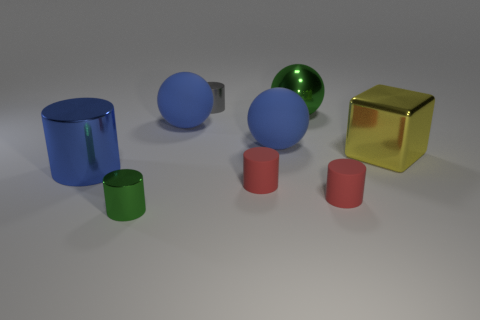Subtract all green cylinders. How many cylinders are left? 4 Subtract all green spheres. How many spheres are left? 2 Subtract 1 green spheres. How many objects are left? 8 Subtract all cylinders. How many objects are left? 4 Subtract 1 cubes. How many cubes are left? 0 Subtract all yellow cylinders. Subtract all blue spheres. How many cylinders are left? 5 Subtract all yellow balls. How many red cylinders are left? 2 Subtract all matte things. Subtract all shiny things. How many objects are left? 0 Add 2 shiny blocks. How many shiny blocks are left? 3 Add 2 yellow objects. How many yellow objects exist? 3 